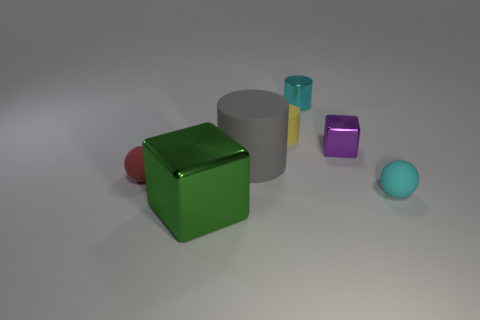What size is the other object that is the same shape as the small red rubber object?
Your answer should be very brief. Small. Do the tiny rubber cylinder and the tiny rubber sphere that is left of the yellow rubber object have the same color?
Provide a succinct answer. No. Does the small rubber cylinder have the same color as the tiny metal block?
Give a very brief answer. No. Is the number of blue matte blocks less than the number of small yellow things?
Keep it short and to the point. Yes. What number of other things are there of the same color as the big metallic thing?
Your answer should be very brief. 0. How many tiny gray metal things are there?
Your answer should be compact. 0. Is the number of small balls that are behind the small cyan shiny cylinder less than the number of balls?
Your answer should be very brief. Yes. Do the tiny ball right of the large green block and the small red thing have the same material?
Make the answer very short. Yes. There is a tiny red rubber thing that is in front of the metal block behind the tiny thing that is to the left of the green metallic cube; what shape is it?
Your answer should be compact. Sphere. Is there a purple shiny block that has the same size as the cyan ball?
Your answer should be compact. Yes. 